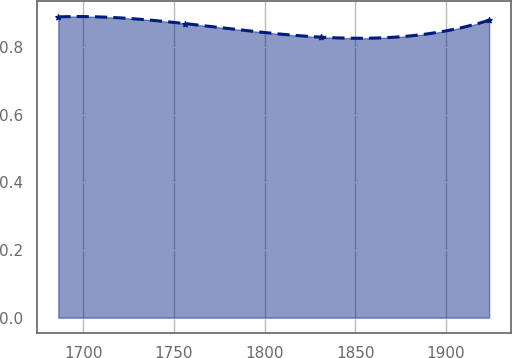<chart> <loc_0><loc_0><loc_500><loc_500><line_chart><ecel><fcel>Unnamed: 1<nl><fcel>1686.35<fcel>0.89<nl><fcel>1756.38<fcel>0.87<nl><fcel>1830.93<fcel>0.83<nl><fcel>1923.77<fcel>0.88<nl></chart> 